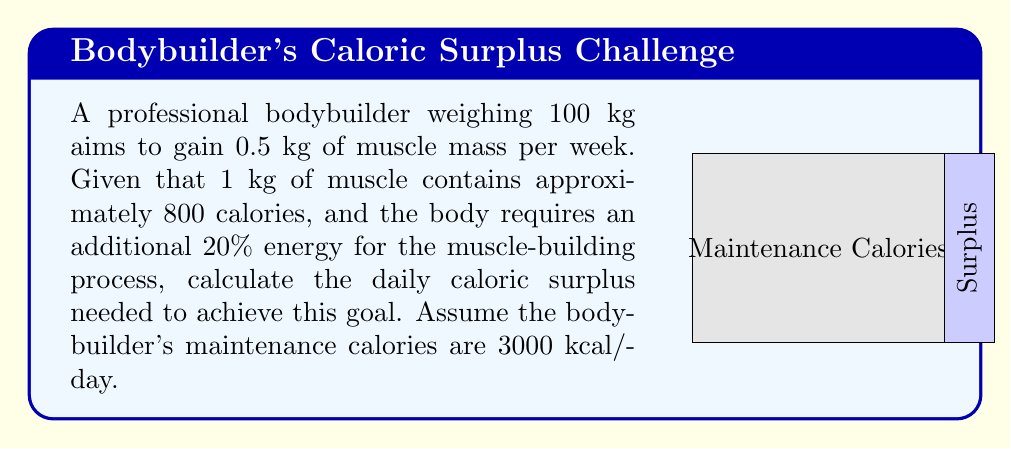Give your solution to this math problem. Let's break this down step-by-step:

1) First, calculate the calories needed for 0.5 kg of muscle:
   $$ 0.5 \text{ kg} \times 800 \text{ kcal/kg} = 400 \text{ kcal} $$

2) Account for the additional 20% energy needed for the muscle-building process:
   $$ 400 \text{ kcal} \times 1.2 = 480 \text{ kcal} $$

3) This is the total caloric surplus needed per week. To find the daily surplus, divide by 7:
   $$ \frac{480 \text{ kcal}}{7 \text{ days}} = 68.57 \text{ kcal/day} $$

4) Round up to the nearest whole number for practical purposes:
   $$ 68.57 \text{ kcal/day} \approx 69 \text{ kcal/day} $$

5) The total daily caloric intake would be:
   $$ 3000 \text{ kcal} + 69 \text{ kcal} = 3069 \text{ kcal} $$

Therefore, the bodybuilder needs a daily caloric surplus of 69 kcal above their maintenance calories to achieve the desired muscle growth rate.
Answer: 69 kcal/day 